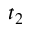Convert formula to latex. <formula><loc_0><loc_0><loc_500><loc_500>t _ { 2 }</formula> 